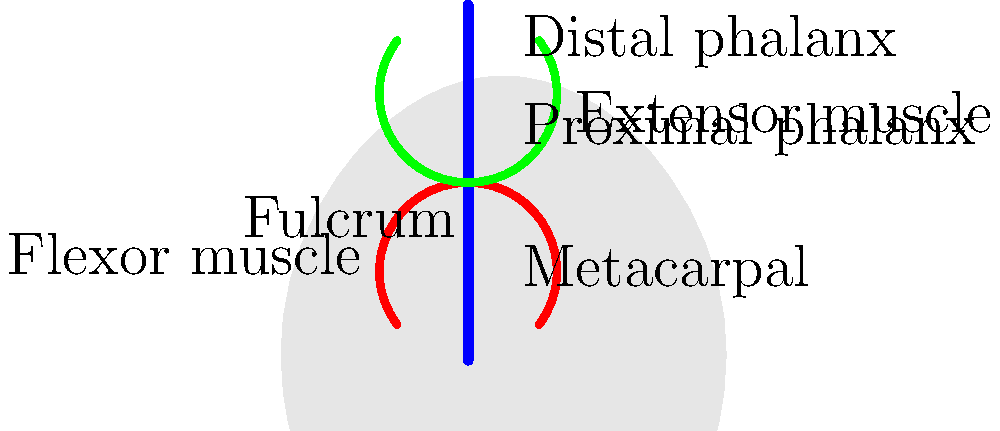In the human hand, which type of lever system is demonstrated when you flex your finger to grip an object, and what are the locations of the effort, fulcrum, and load in this system? To answer this question, let's analyze the lever system in the finger:

1. Identify the components:
   - The bones act as the rigid lever
   - The joint (between metacarpal and proximal phalanx) acts as the fulcrum
   - The flexor muscle provides the effort
   - The object being gripped provides the load

2. Determine the arrangement:
   - The fulcrum (joint) is between the effort (muscle attachment) and the load (fingertip)

3. Classify the lever system:
   - This arrangement corresponds to a Class III lever system

4. Locate the components:
   - Effort: Near the fulcrum, where the flexor muscle attaches to the proximal phalanx
   - Fulcrum: At the metacarpophalangeal joint (base of the finger)
   - Load: At the fingertip, farthest from the fulcrum

5. Understand the mechanical advantage:
   - In a Class III lever, the effort is always greater than the load
   - This system sacrifices force for increased speed and range of motion

6. Relate to function:
   - This arrangement allows for precise control and quick movements of the fingers, which is crucial for tasks requiring dexterity
Answer: Class III lever; Effort near fulcrum (muscle attachment), Fulcrum at joint, Load at fingertip 